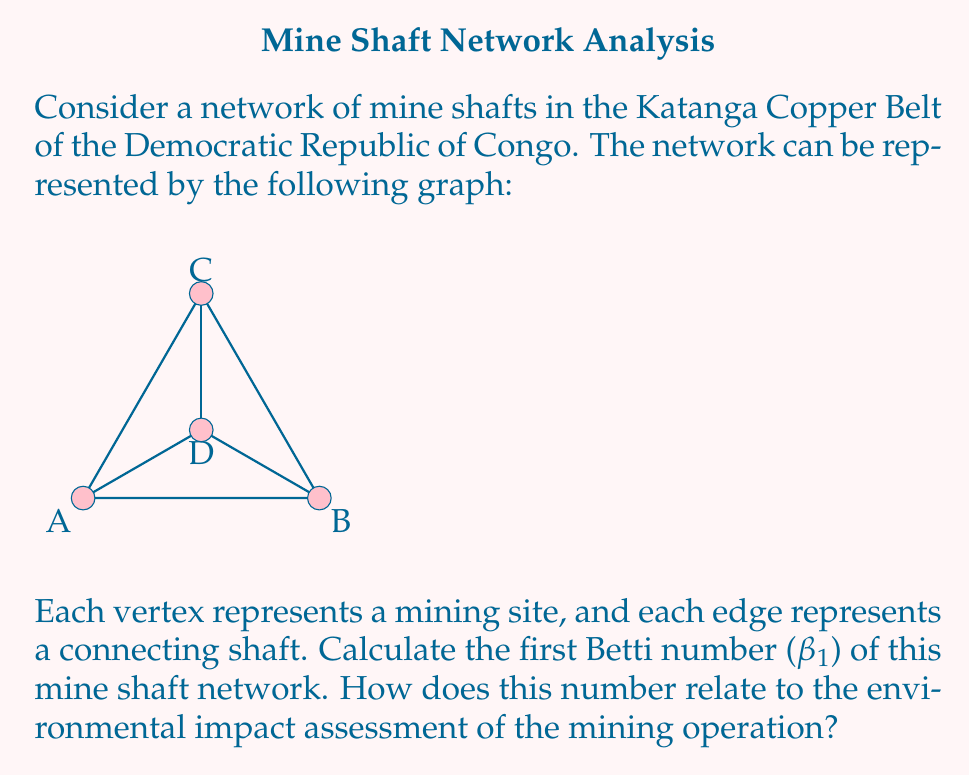Can you answer this question? To solve this problem, we'll follow these steps:

1) The first Betti number $$\beta_1$$ is equal to the number of cycles in the graph. It can be calculated using the formula:

   $$\beta_1 = E - V + 1$$

   where E is the number of edges and V is the number of vertices.

2) In this graph:
   - Number of vertices (V) = 4 (A, B, C, D)
   - Number of edges (E) = 6 (AB, BC, CA, AD, BD, CD)

3) Applying the formula:

   $$\beta_1 = 6 - 4 + 1 = 3$$

4) This means there are 3 independent cycles in the graph.

5) In the context of environmental impact assessment:
   - Each cycle represents a closed loop in the mine shaft network.
   - More cycles (higher $$\beta_1$$) indicate a more complex and interconnected mining operation.
   - This complexity can lead to:
     a) Increased risk of groundwater contamination due to multiple pathways.
     b) Greater potential for soil subsidence and surface deformation.
     c) More challenging ventilation and safety management.
   - Therefore, a higher $$\beta_1$$ generally implies a potentially greater environmental impact and more complex mitigation strategies.
Answer: $$\beta_1 = 3$$; Higher $$\beta_1$$ indicates greater potential environmental impact. 